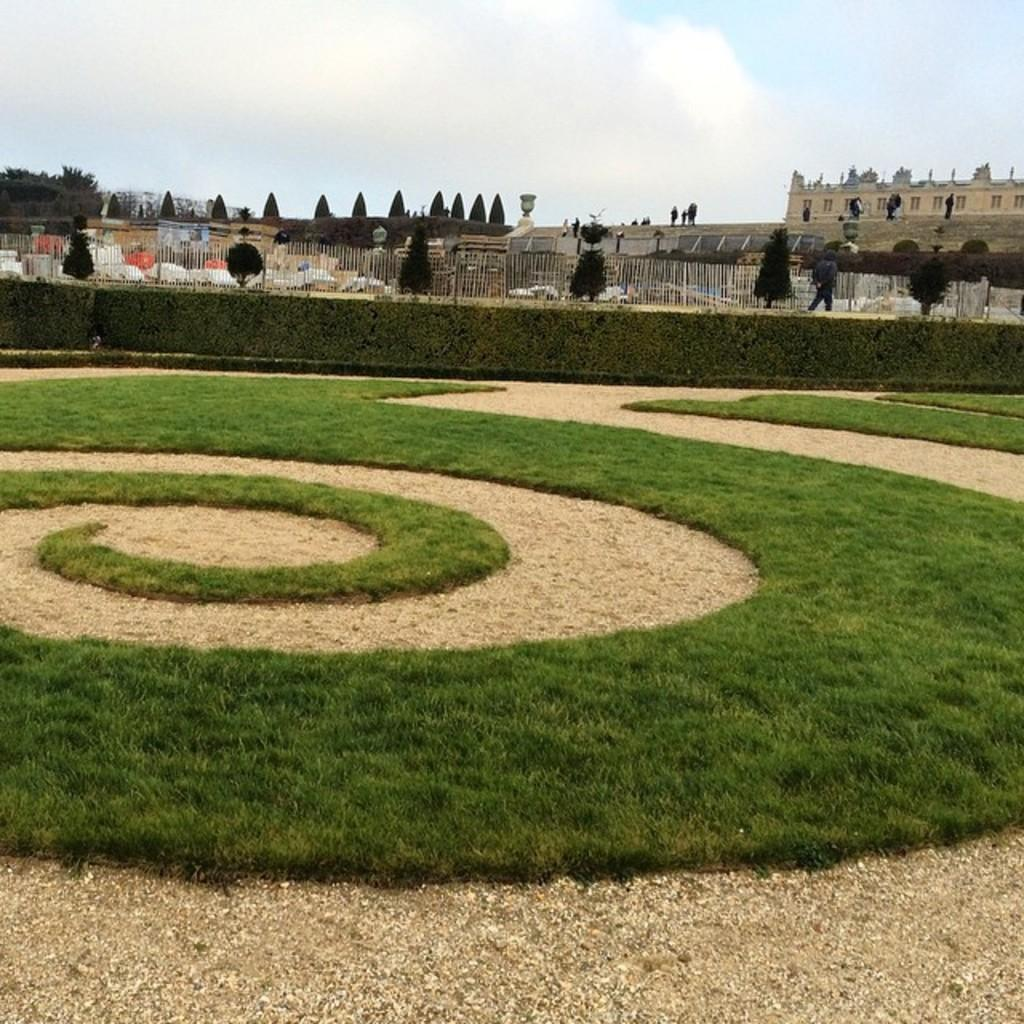What type of structures can be seen in the image? There are many buildings in the image. What else is present in the image besides buildings? There are trees, a fence, grass, and sand in the image. What is the condition of the sky in the image? The sky is cloudy and pale blue in the image. What type of education is being offered at the van in the image? There is no van present in the image, so no education is being offered. On which side of the image is the van located? There is no van present in the image, so it cannot be located on any side. 